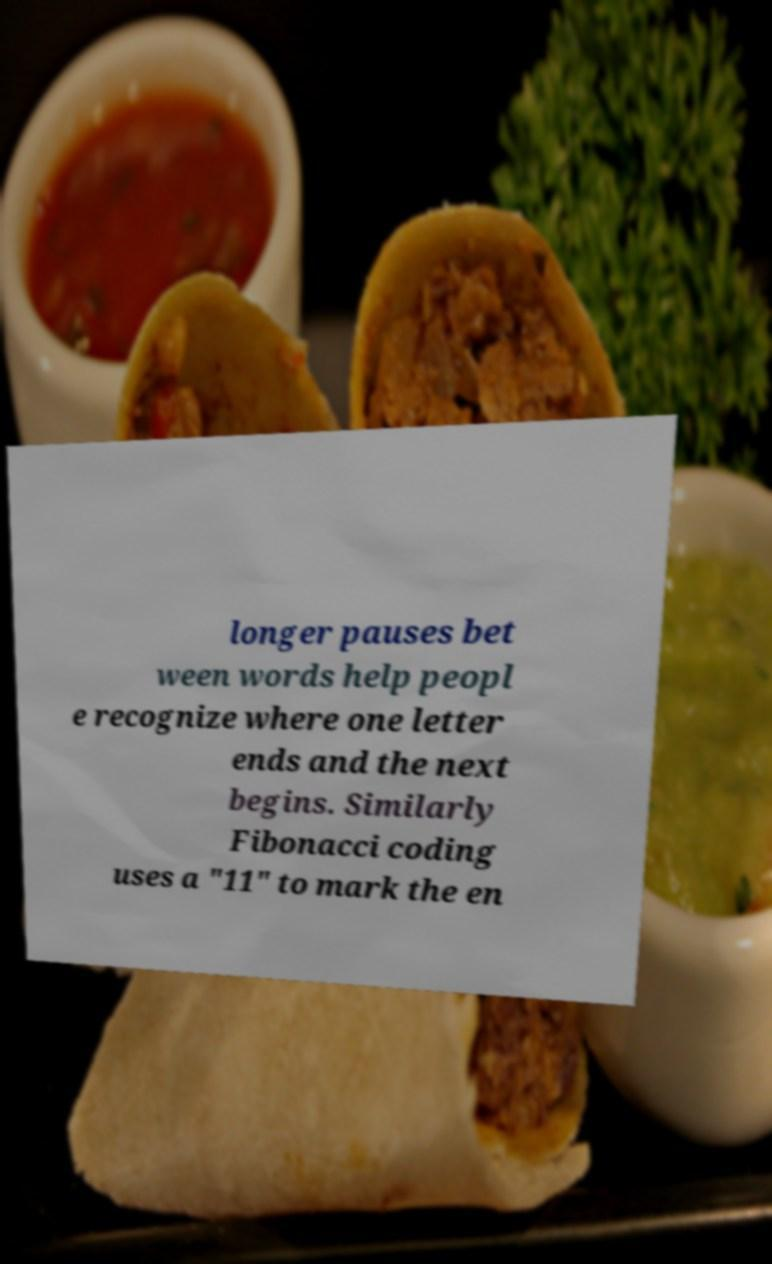Could you extract and type out the text from this image? longer pauses bet ween words help peopl e recognize where one letter ends and the next begins. Similarly Fibonacci coding uses a "11" to mark the en 